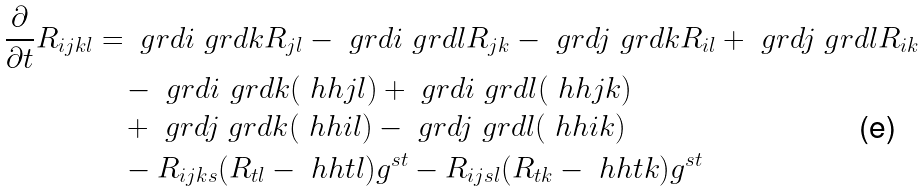<formula> <loc_0><loc_0><loc_500><loc_500>\frac { \partial } { \partial t } R _ { i j k l } & = \ g r d { i } \ g r d { k } R _ { j l } - \ g r d { i } \ g r d { l } R _ { j k } - \ g r d { j } \ g r d { k } R _ { i l } + \ g r d { j } \ g r d { l } R _ { i k } \\ & \quad - \ g r d { i } \ g r d { k } ( \ h h { j } { l } ) + \ g r d { i } \ g r d { l } ( \ h h { j } { k } ) \\ & \quad + \ g r d { j } \ g r d { k } ( \ h h { i } { l } ) - \ g r d { j } \ g r d { l } ( \ h h { i } { k } ) \\ & \quad - R _ { i j k s } ( R _ { t l } - \ h h { t } { l } ) g ^ { s t } - R _ { i j s l } ( R _ { t k } - \ h h { t } { k } ) g ^ { s t } \\</formula> 